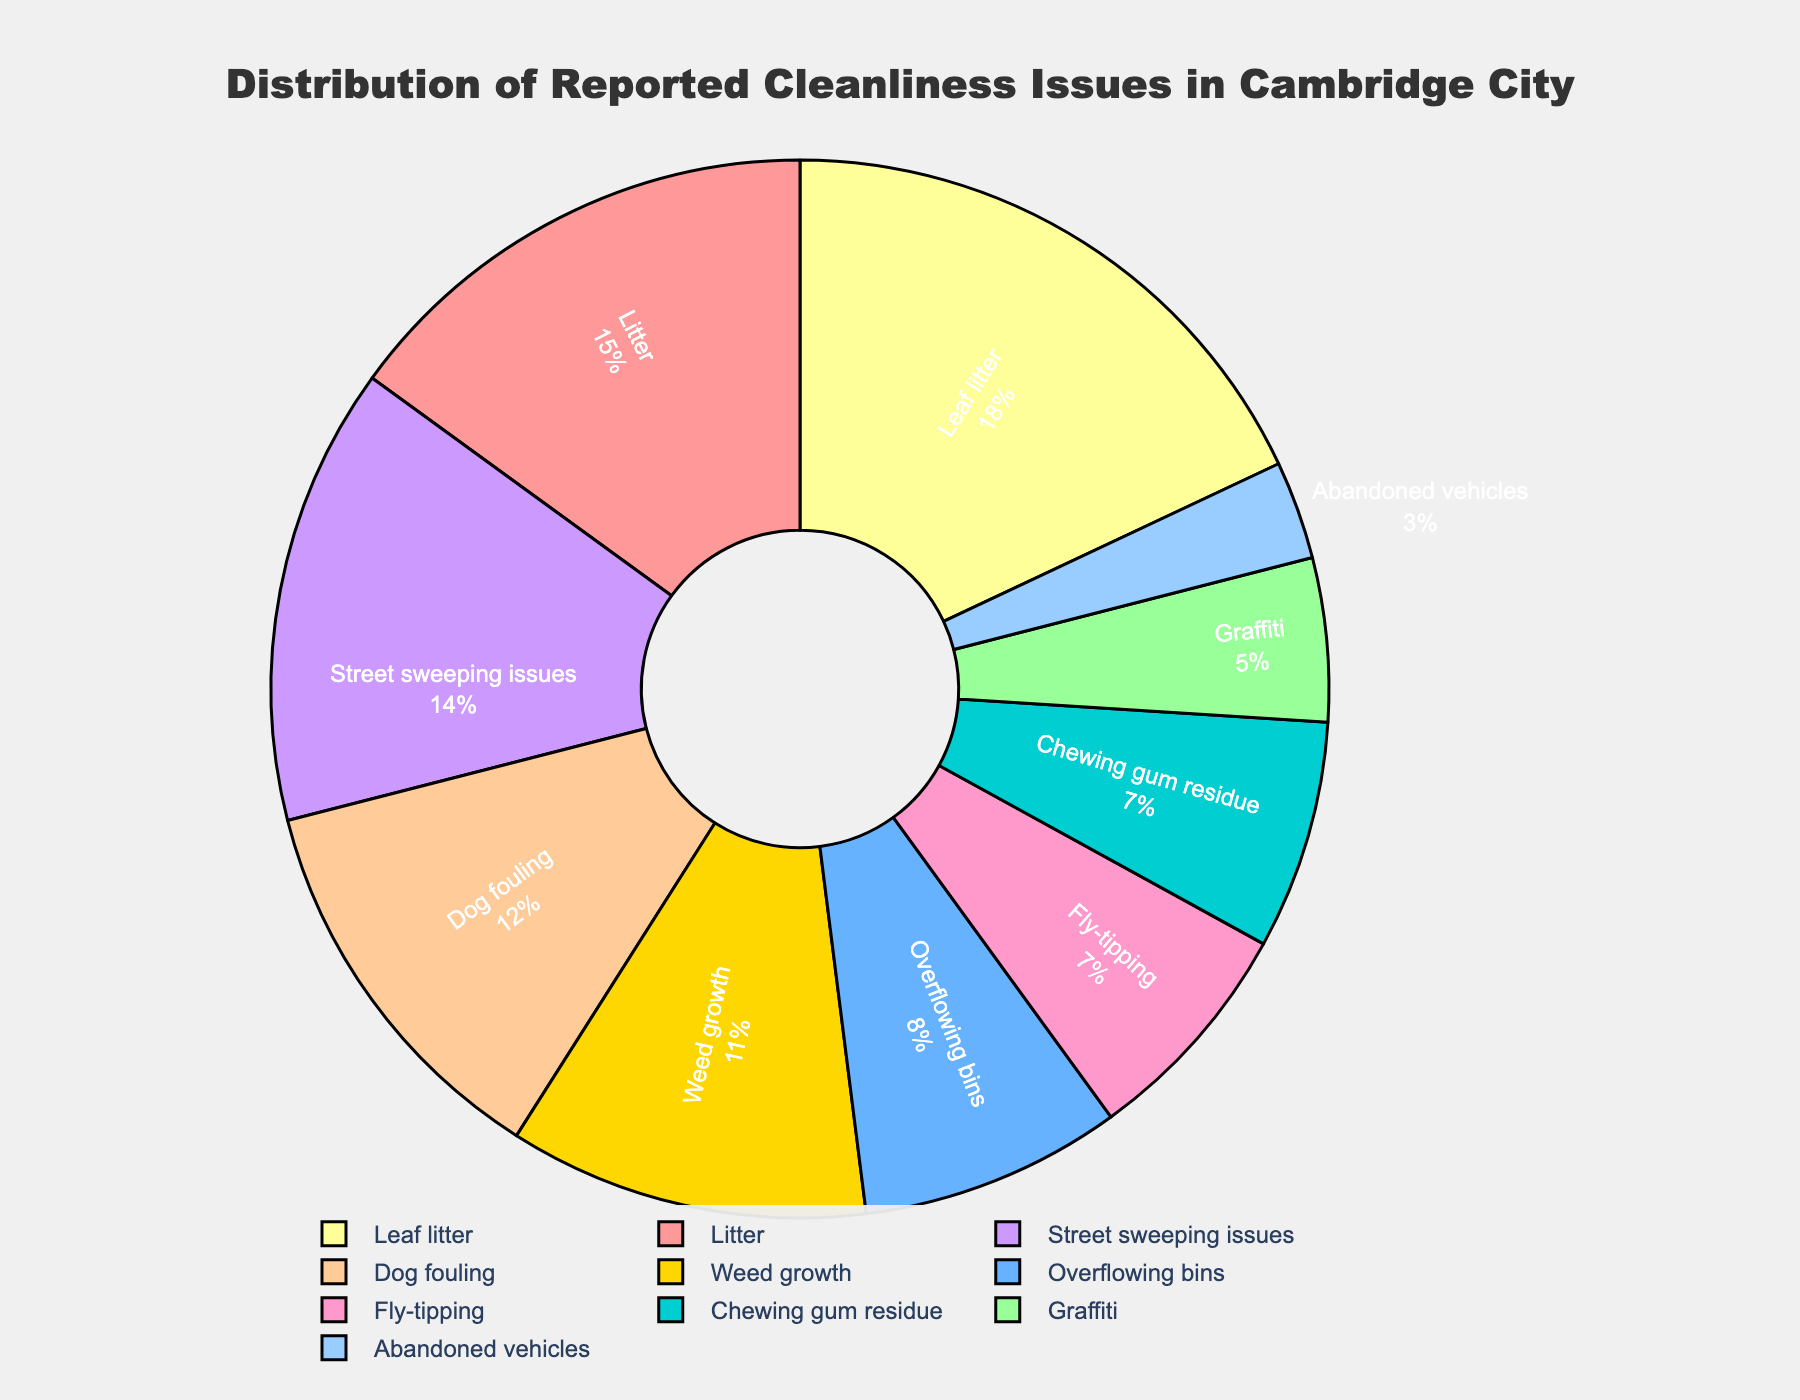What percentage of reported cleanliness issues is due to "Street sweeping issues"? To find the percentage of reported cleanliness issues due to "Street sweeping issues," look at the specified segment in the pie chart. The chart displays "Street sweeping issues" and its associated percentage on the slice.
Answer: 14% Which category has the highest percentage of reported cleanliness issues? To determine the category with the highest percentage, compare all the slices and identify the one with the largest proportion. The chart indicates that "Leaf litter" has the highest percentage.
Answer: Leaf litter What is the total percentage of reported cleanliness issues caused by "Litter", "Dog fouling", and "Street sweeping issues"? Add up the percentages for the categories "Litter" (15%), "Dog fouling" (12%), and "Street sweeping issues" (14%). The sum is calculated by: 15 + 12 + 14.
Answer: 41% Which is more common, "Overflowing bins" or "Chewing gum residue"? To ascertain which is more common, compare the percentages of "Overflowing bins" and "Chewing gum residue". "Overflowing bins" has a higher percentage than "Chewing gum residue" according to the pie chart.
Answer: Overflowing bins Are there more reported issues due to "Graffiti" or "Abandoned vehicles"? Compare the percentages of "Graffiti" and "Abandoned vehicles." The pie chart shows "Graffiti" at 5% and "Abandoned vehicles" at 3%, indicating that "Graffiti" is more common.
Answer: Graffiti Which category has a smaller percentage: "Fly-tipping" or "Weed growth"? Compare the percentages for the categories "Fly-tipping" (7%) and "Weed growth" (11%). "Fly-tipping" has a smaller percentage.
Answer: Fly-tipping What is the combined percentage of cleanliness issues attributed to "Leaf litter" and "Weed growth"? Sum the percentages for "Leaf litter" (18%) and "Weed growth" (11%). The total is calculated as: 18 + 11.
Answer: 29% Which color represents the "Dog fouling" category in the pie chart? To identify the color representing "Dog fouling," find the segment labeled "Dog fouling" and note its color. The color is light orange (coded as "#FFCC99" in the data).
Answer: Light orange 